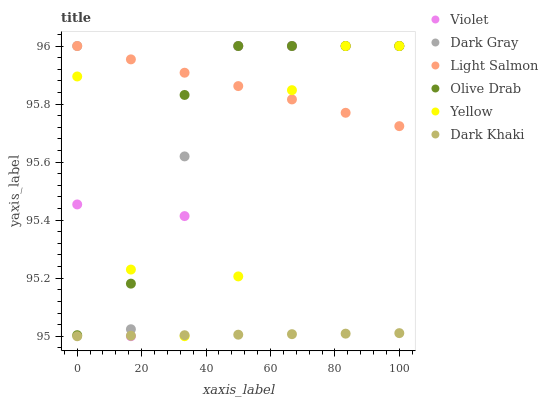Does Dark Khaki have the minimum area under the curve?
Answer yes or no. Yes. Does Light Salmon have the maximum area under the curve?
Answer yes or no. Yes. Does Yellow have the minimum area under the curve?
Answer yes or no. No. Does Yellow have the maximum area under the curve?
Answer yes or no. No. Is Dark Khaki the smoothest?
Answer yes or no. Yes. Is Dark Gray the roughest?
Answer yes or no. Yes. Is Light Salmon the smoothest?
Answer yes or no. No. Is Light Salmon the roughest?
Answer yes or no. No. Does Dark Khaki have the lowest value?
Answer yes or no. Yes. Does Yellow have the lowest value?
Answer yes or no. No. Does Olive Drab have the highest value?
Answer yes or no. Yes. Is Dark Khaki less than Olive Drab?
Answer yes or no. Yes. Is Olive Drab greater than Dark Khaki?
Answer yes or no. Yes. Does Light Salmon intersect Olive Drab?
Answer yes or no. Yes. Is Light Salmon less than Olive Drab?
Answer yes or no. No. Is Light Salmon greater than Olive Drab?
Answer yes or no. No. Does Dark Khaki intersect Olive Drab?
Answer yes or no. No. 